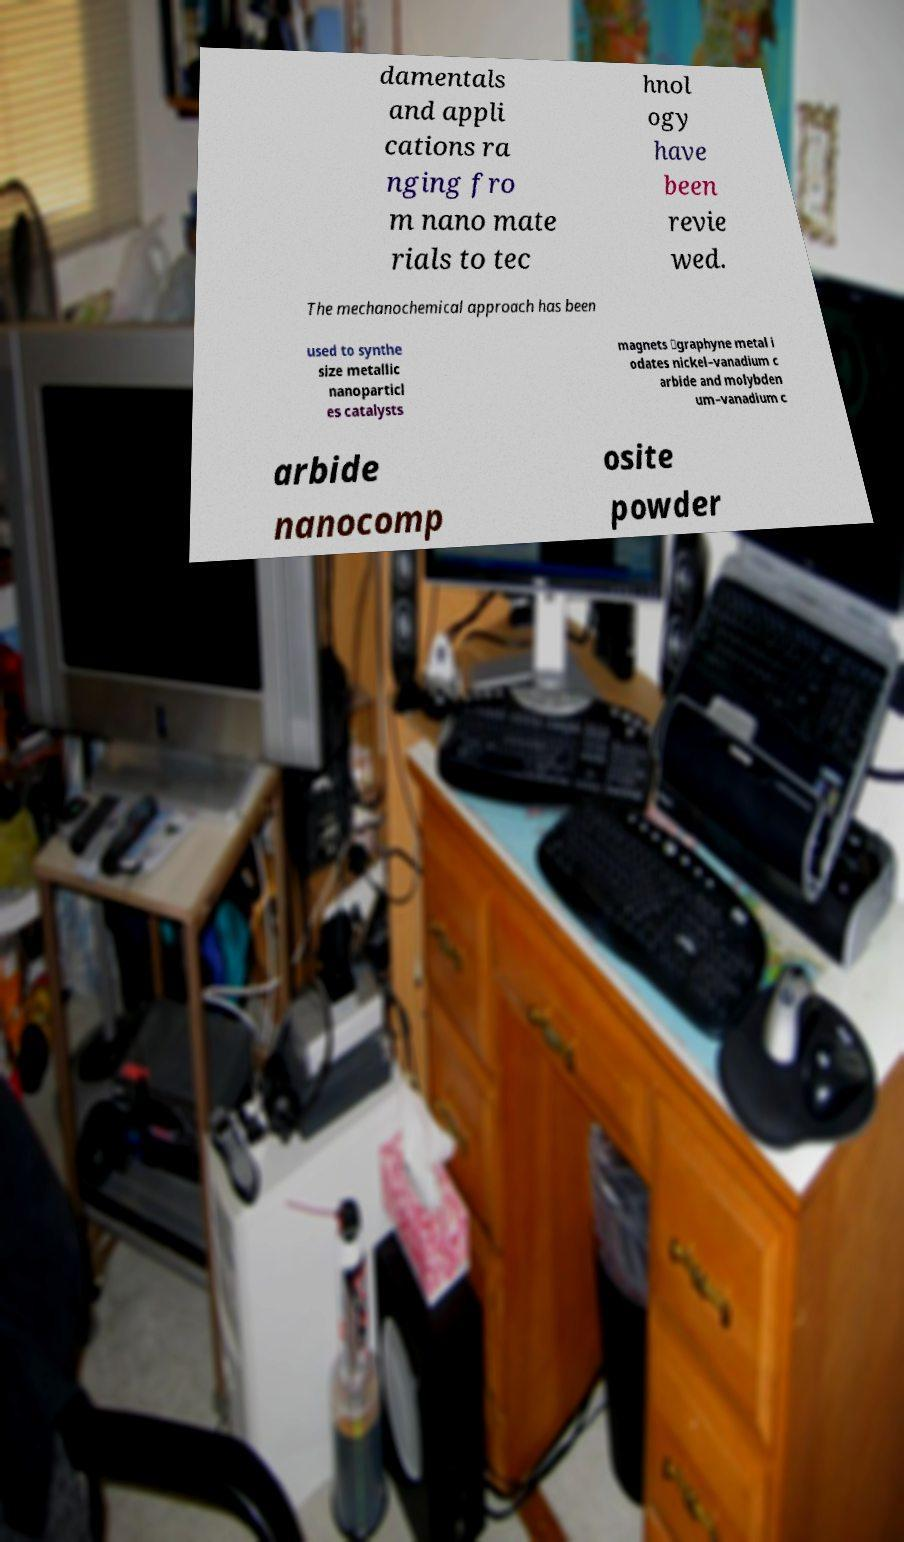There's text embedded in this image that I need extracted. Can you transcribe it verbatim? damentals and appli cations ra nging fro m nano mate rials to tec hnol ogy have been revie wed. The mechanochemical approach has been used to synthe size metallic nanoparticl es catalysts magnets ‐graphyne metal i odates nickel–vanadium c arbide and molybden um–vanadium c arbide nanocomp osite powder 